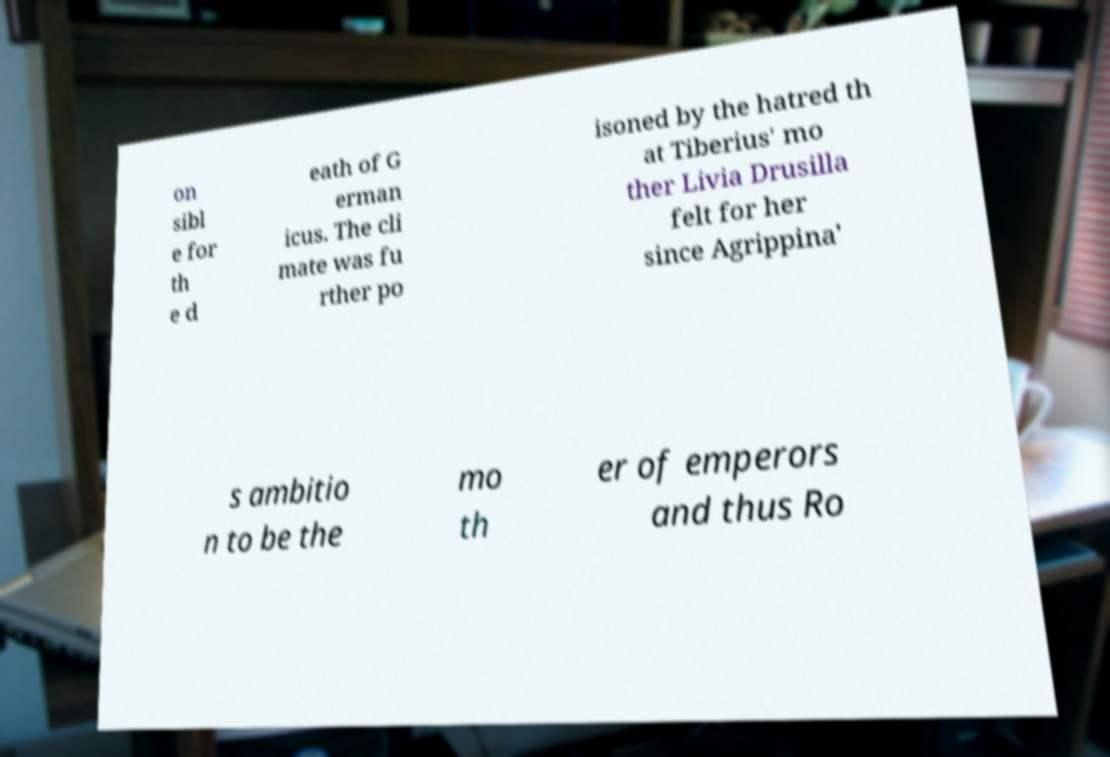Please read and relay the text visible in this image. What does it say? on sibl e for th e d eath of G erman icus. The cli mate was fu rther po isoned by the hatred th at Tiberius' mo ther Livia Drusilla felt for her since Agrippina' s ambitio n to be the mo th er of emperors and thus Ro 